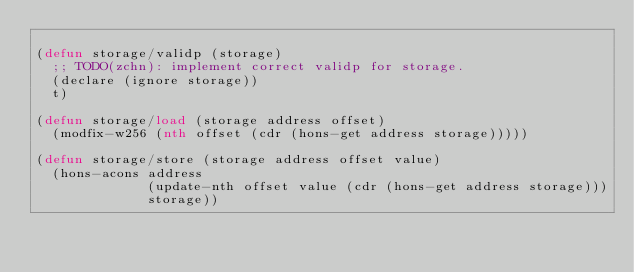Convert code to text. <code><loc_0><loc_0><loc_500><loc_500><_Lisp_>
(defun storage/validp (storage)
  ;; TODO(zchn): implement correct validp for storage.
  (declare (ignore storage))
  t)

(defun storage/load (storage address offset)
  (modfix-w256 (nth offset (cdr (hons-get address storage)))))

(defun storage/store (storage address offset value)
  (hons-acons address
              (update-nth offset value (cdr (hons-get address storage)))
              storage))
</code> 